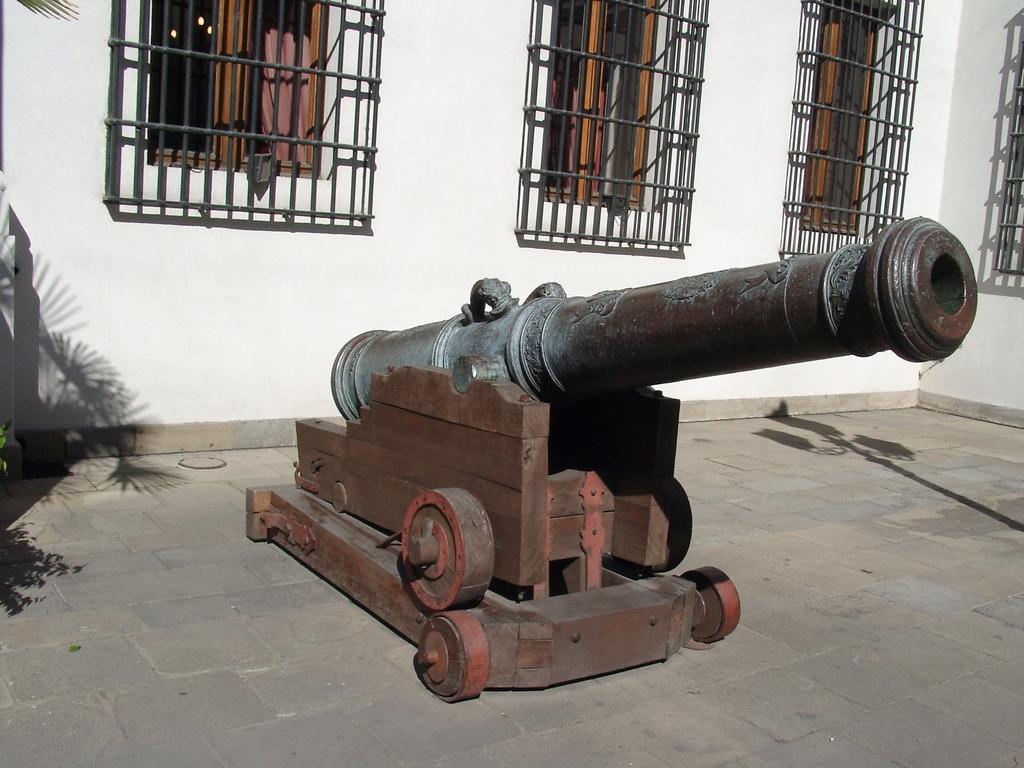Could you give a brief overview of what you see in this image? In this image there is a weapon kept on the trolley which is on the floor. Behind it there is a wall having few windows which is covered with metal grill. Behind the windows there are curtains. 